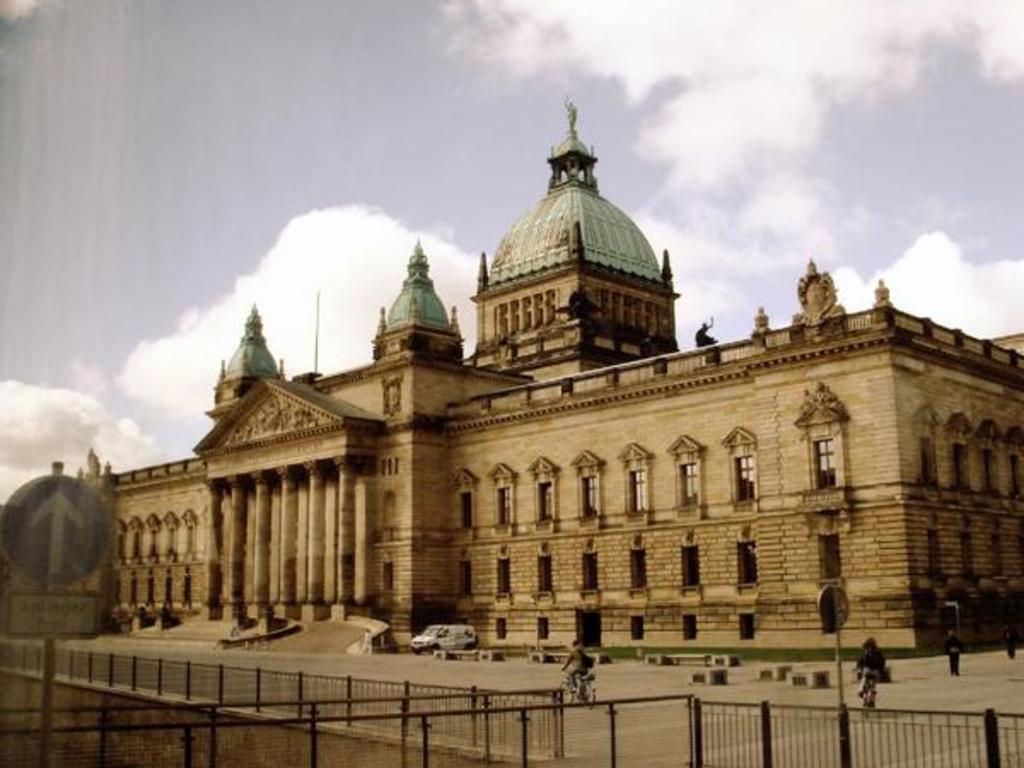Please provide a concise description of this image. In this picture we can see a building, at the bottom there is fencing, there are two persons riding bicycles, we can see a van in the middle, on the left side there is a board, we can see the sky and clouds at the top of the picture. 